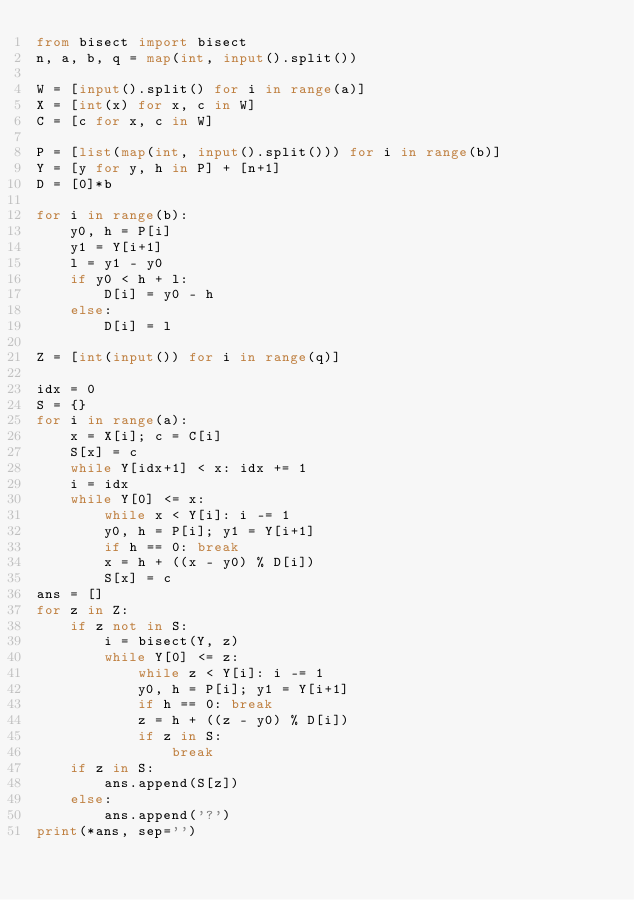<code> <loc_0><loc_0><loc_500><loc_500><_Python_>from bisect import bisect
n, a, b, q = map(int, input().split())

W = [input().split() for i in range(a)]
X = [int(x) for x, c in W]
C = [c for x, c in W]

P = [list(map(int, input().split())) for i in range(b)]
Y = [y for y, h in P] + [n+1]
D = [0]*b

for i in range(b):
    y0, h = P[i]
    y1 = Y[i+1]
    l = y1 - y0
    if y0 < h + l:
        D[i] = y0 - h
    else:
        D[i] = l

Z = [int(input()) for i in range(q)]

idx = 0
S = {}
for i in range(a):
    x = X[i]; c = C[i]
    S[x] = c
    while Y[idx+1] < x: idx += 1
    i = idx
    while Y[0] <= x:
        while x < Y[i]: i -= 1
        y0, h = P[i]; y1 = Y[i+1]
        if h == 0: break
        x = h + ((x - y0) % D[i])
        S[x] = c
ans = []
for z in Z:
    if z not in S:
        i = bisect(Y, z)
        while Y[0] <= z:
            while z < Y[i]: i -= 1
            y0, h = P[i]; y1 = Y[i+1]
            if h == 0: break
            z = h + ((z - y0) % D[i])
            if z in S:
                break
    if z in S:
        ans.append(S[z])
    else:
        ans.append('?')
print(*ans, sep='')</code> 